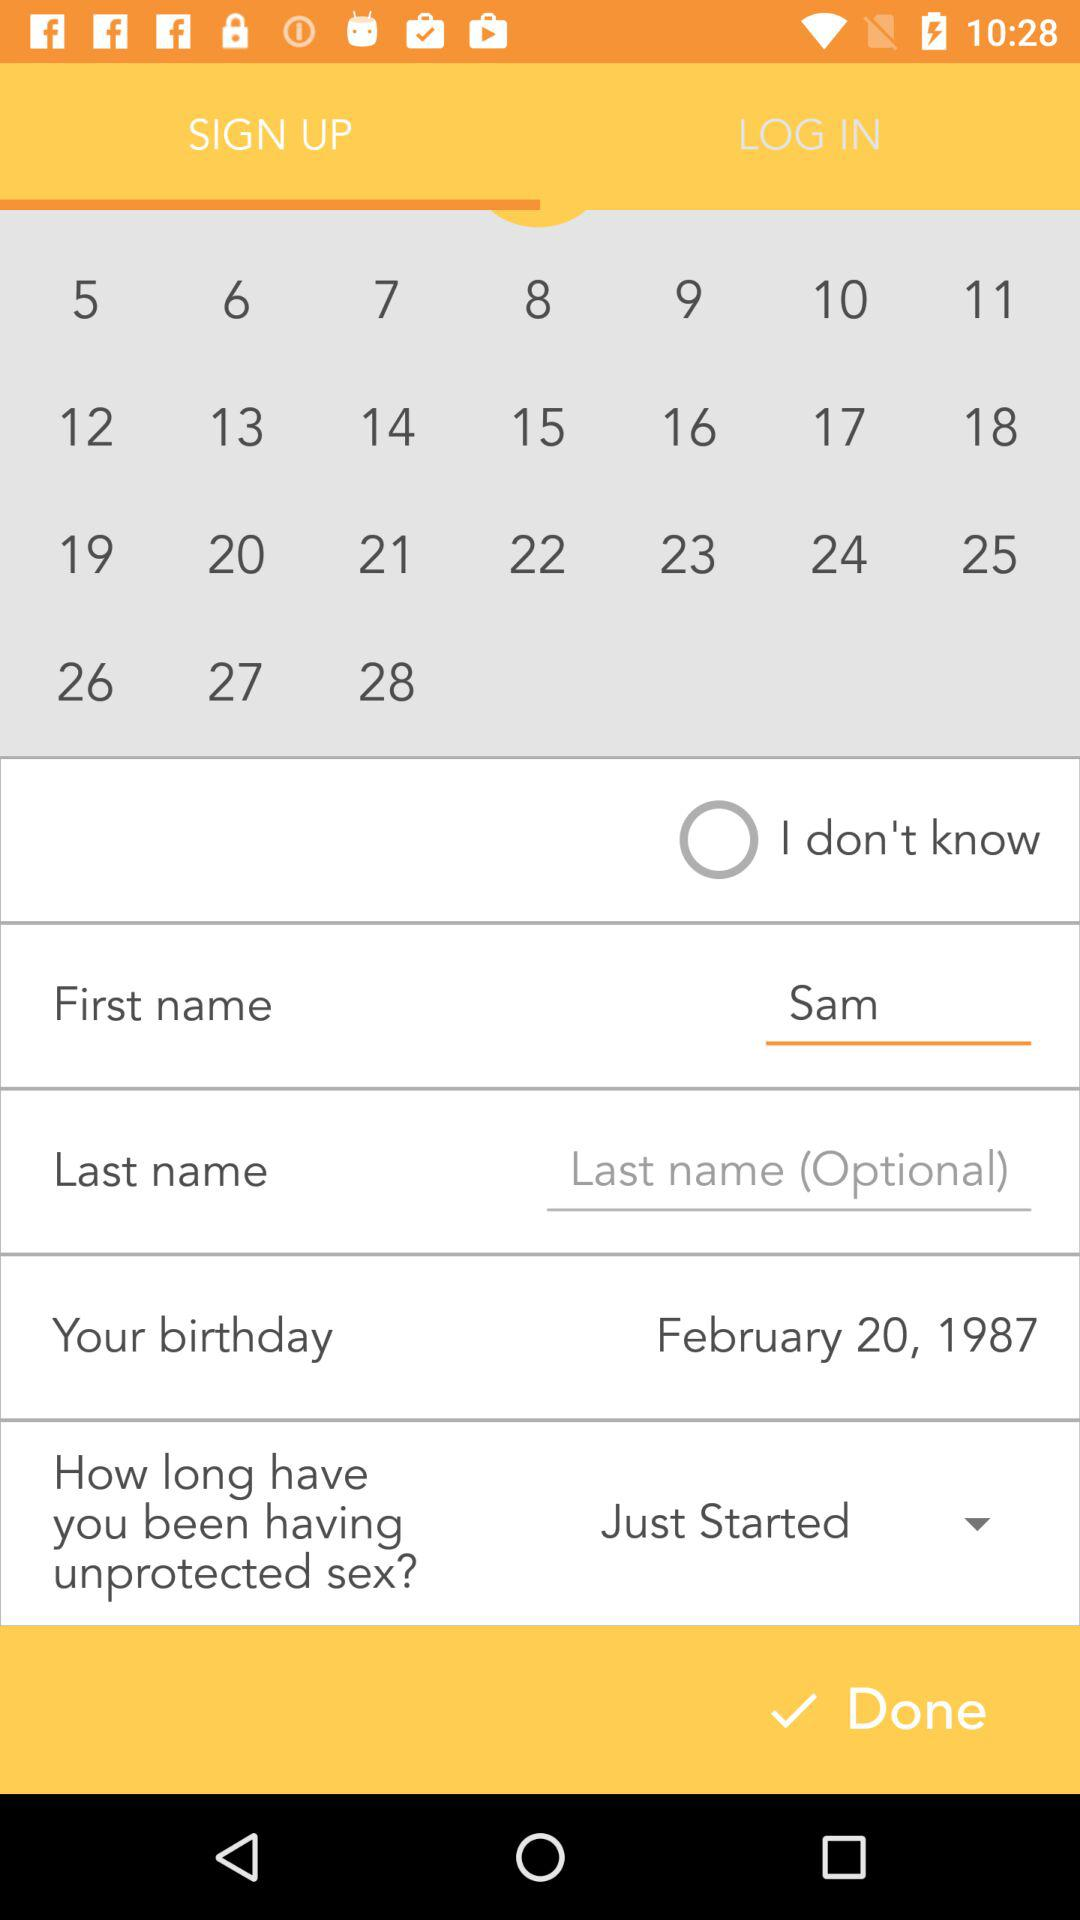How many text inputs are there that are not optional?
Answer the question using a single word or phrase. 2 